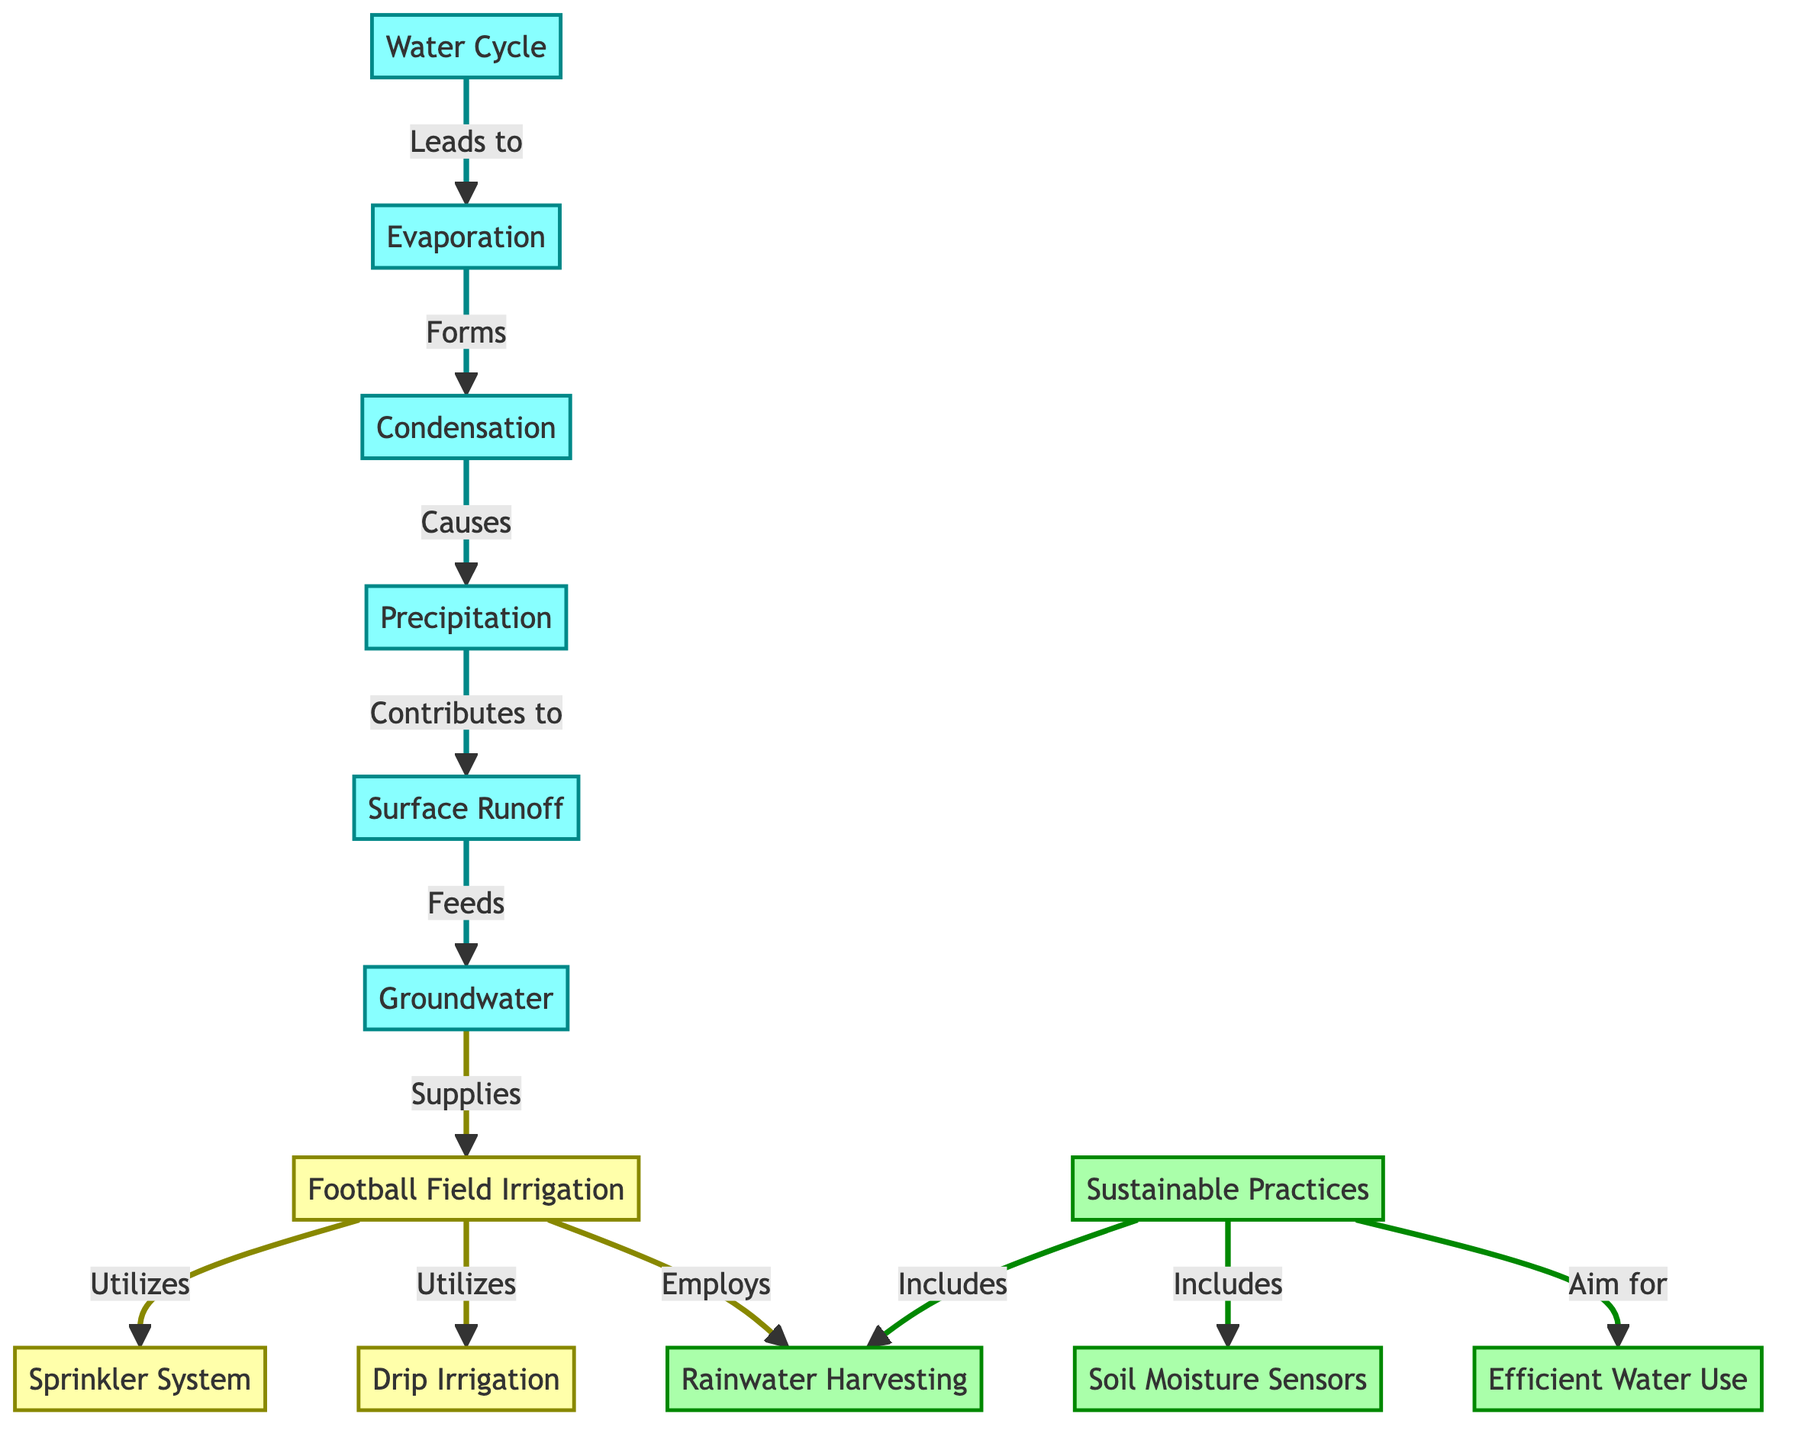What are the first two steps in the water cycle? The first two steps in the water cycle as shown in the diagram are "Evaporation" followed by "Condensation." These are connected directly in a sequential manner, indicating the flow from evaporation to condensation.
Answer: Evaporation, Condensation How many irrigation methods are listed in the diagram? The diagram includes two methods of irrigation that are explicitly named: "Sprinkler System" and "Drip Irrigation." By counting these two nodes, we can determine the number of methods.
Answer: 2 What sustainable practice utilizes rainwater? The practice that utilizes rainwater is "Rainwater Harvesting," which is directly indicated in the "Sustainable Practices" part of the diagram. This node is marked as part of the sustainable efforts in irrigation.
Answer: Rainwater Harvesting Which node leads to the "Groundwater" node? The node that leads to "Groundwater" is "Surface Runoff." The diagram shows a direct flow from the surface runoff, indicating where the groundwater originates.
Answer: Surface Runoff How does the "Football Field Irrigation" utilize "Efficient Water Use"? The "Football Field Irrigation" employs "Efficient Water Use" as a part of its sustainable practices, demonstrating how irrigation systems can incorporate methods to save water resources. This relationship is established in the connections shown in the diagram.
Answer: Employs What contributes to "Precipitation"? "Condensation" contributes to "Precipitation" according to the diagram. This step indicates the transformation of condensed water vapor into precipitation, which is a crucial stage in the water cycle.
Answer: Condensation What is the connection between "Soil Moisture Sensors" and "Sustainable Practices"? "Soil Moisture Sensors" are included as part of "Sustainable Practices." This connection indicates that monitoring soil moisture is an important effort towards sustainability in irrigation.
Answer: Includes Which node indicates the method used for field irrigation? The "Football Field Irrigation" node indicates the methods for field irrigation, with specific systems such as "Sprinkler System" and "Drip Irrigation" being branches from it.
Answer: Football Field Irrigation What supplies the "Football Field Irrigation"? The node that supplies the "Football Field Irrigation" is "Groundwater," showing that underground water resources are utilized to maintain the irrigation systems for the football field.
Answer: Groundwater 